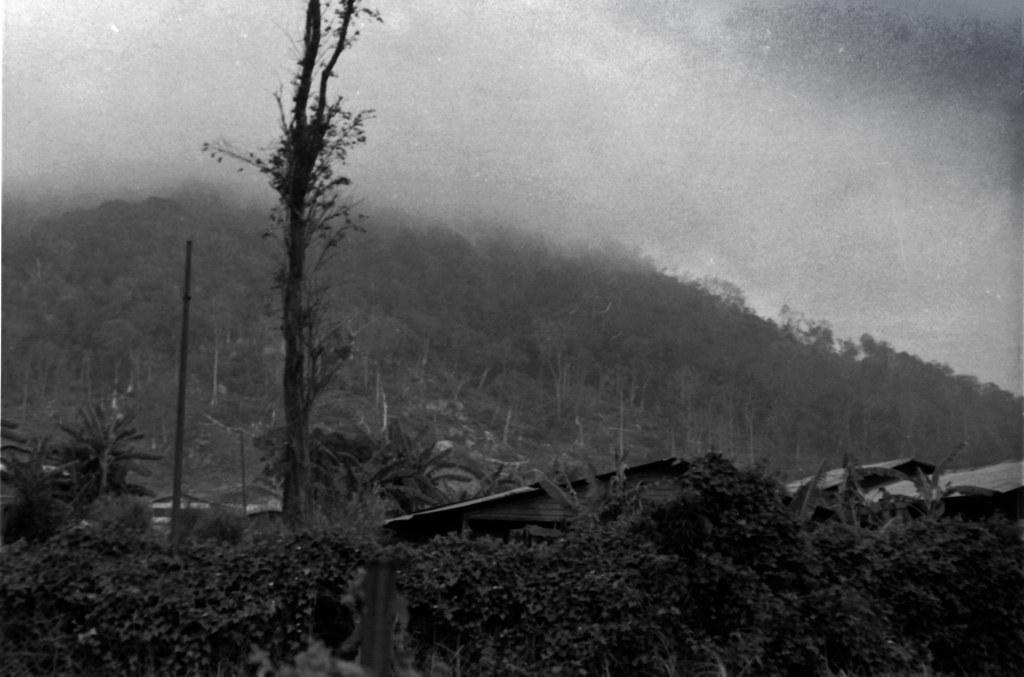What type of vegetation can be seen in the image? There are trees in the image. What type of structures are present in the image? There are houses in the image. What other objects can be seen in the image? There are poles in the image. What natural feature is visible in the image? There is a mountain in the image. What is visible in the background of the image? The sky is visible in the background of the image. What type of leg can be seen on the mountain in the image? There are no legs present on the mountain in the image; it is a natural feature. How does the fog affect the visibility of the houses in the image? There is no fog present in the image; the sky is visible in the background. 